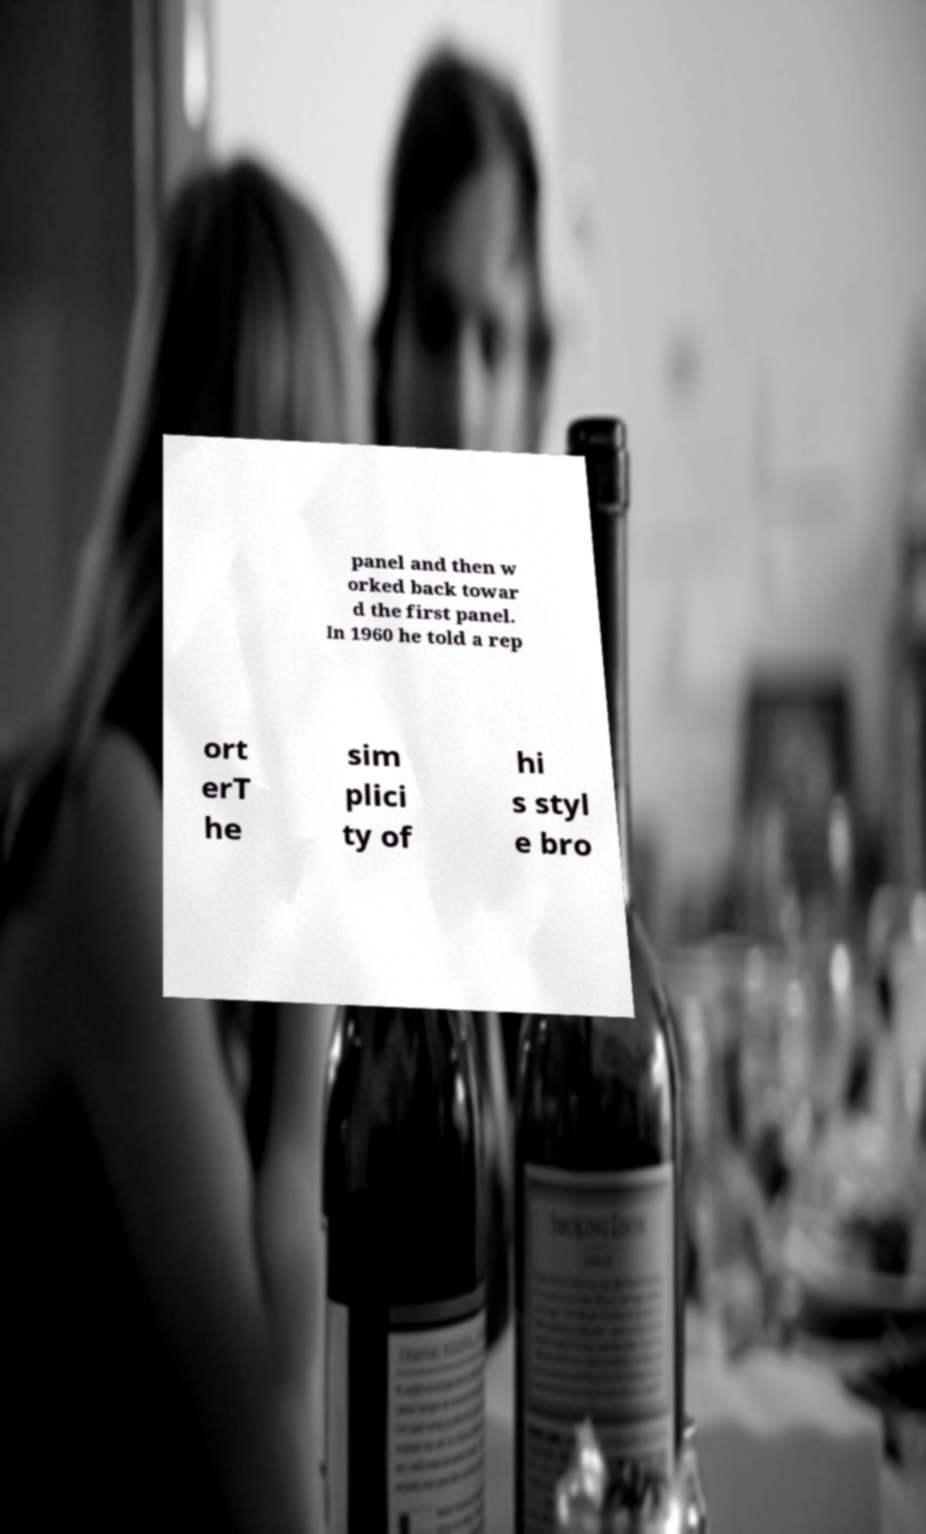Please identify and transcribe the text found in this image. panel and then w orked back towar d the first panel. In 1960 he told a rep ort erT he sim plici ty of hi s styl e bro 